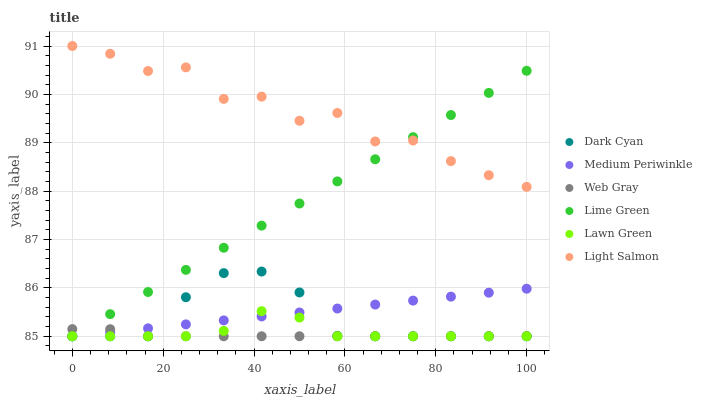Does Web Gray have the minimum area under the curve?
Answer yes or no. Yes. Does Light Salmon have the maximum area under the curve?
Answer yes or no. Yes. Does Light Salmon have the minimum area under the curve?
Answer yes or no. No. Does Web Gray have the maximum area under the curve?
Answer yes or no. No. Is Medium Periwinkle the smoothest?
Answer yes or no. Yes. Is Light Salmon the roughest?
Answer yes or no. Yes. Is Web Gray the smoothest?
Answer yes or no. No. Is Web Gray the roughest?
Answer yes or no. No. Does Lawn Green have the lowest value?
Answer yes or no. Yes. Does Light Salmon have the lowest value?
Answer yes or no. No. Does Light Salmon have the highest value?
Answer yes or no. Yes. Does Web Gray have the highest value?
Answer yes or no. No. Is Lawn Green less than Light Salmon?
Answer yes or no. Yes. Is Light Salmon greater than Lawn Green?
Answer yes or no. Yes. Does Medium Periwinkle intersect Dark Cyan?
Answer yes or no. Yes. Is Medium Periwinkle less than Dark Cyan?
Answer yes or no. No. Is Medium Periwinkle greater than Dark Cyan?
Answer yes or no. No. Does Lawn Green intersect Light Salmon?
Answer yes or no. No. 